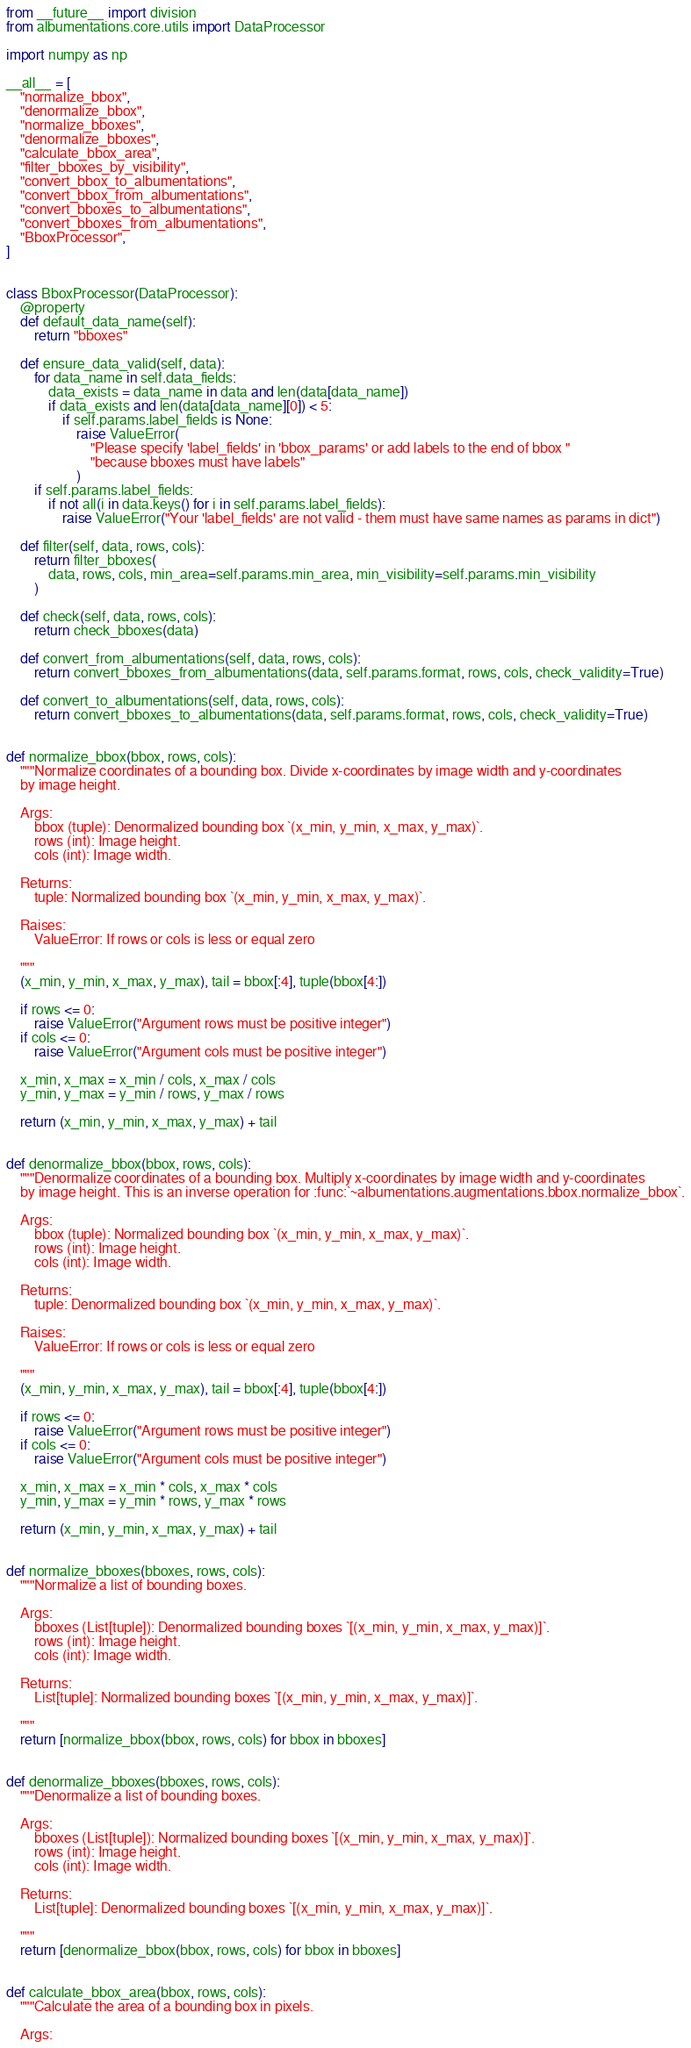Convert code to text. <code><loc_0><loc_0><loc_500><loc_500><_Python_>from __future__ import division
from albumentations.core.utils import DataProcessor

import numpy as np

__all__ = [
    "normalize_bbox",
    "denormalize_bbox",
    "normalize_bboxes",
    "denormalize_bboxes",
    "calculate_bbox_area",
    "filter_bboxes_by_visibility",
    "convert_bbox_to_albumentations",
    "convert_bbox_from_albumentations",
    "convert_bboxes_to_albumentations",
    "convert_bboxes_from_albumentations",
    "BboxProcessor",
]


class BboxProcessor(DataProcessor):
    @property
    def default_data_name(self):
        return "bboxes"

    def ensure_data_valid(self, data):
        for data_name in self.data_fields:
            data_exists = data_name in data and len(data[data_name])
            if data_exists and len(data[data_name][0]) < 5:
                if self.params.label_fields is None:
                    raise ValueError(
                        "Please specify 'label_fields' in 'bbox_params' or add labels to the end of bbox "
                        "because bboxes must have labels"
                    )
        if self.params.label_fields:
            if not all(i in data.keys() for i in self.params.label_fields):
                raise ValueError("Your 'label_fields' are not valid - them must have same names as params in dict")

    def filter(self, data, rows, cols):
        return filter_bboxes(
            data, rows, cols, min_area=self.params.min_area, min_visibility=self.params.min_visibility
        )

    def check(self, data, rows, cols):
        return check_bboxes(data)

    def convert_from_albumentations(self, data, rows, cols):
        return convert_bboxes_from_albumentations(data, self.params.format, rows, cols, check_validity=True)

    def convert_to_albumentations(self, data, rows, cols):
        return convert_bboxes_to_albumentations(data, self.params.format, rows, cols, check_validity=True)


def normalize_bbox(bbox, rows, cols):
    """Normalize coordinates of a bounding box. Divide x-coordinates by image width and y-coordinates
    by image height.

    Args:
        bbox (tuple): Denormalized bounding box `(x_min, y_min, x_max, y_max)`.
        rows (int): Image height.
        cols (int): Image width.

    Returns:
        tuple: Normalized bounding box `(x_min, y_min, x_max, y_max)`.

    Raises:
        ValueError: If rows or cols is less or equal zero

    """
    (x_min, y_min, x_max, y_max), tail = bbox[:4], tuple(bbox[4:])

    if rows <= 0:
        raise ValueError("Argument rows must be positive integer")
    if cols <= 0:
        raise ValueError("Argument cols must be positive integer")

    x_min, x_max = x_min / cols, x_max / cols
    y_min, y_max = y_min / rows, y_max / rows

    return (x_min, y_min, x_max, y_max) + tail


def denormalize_bbox(bbox, rows, cols):
    """Denormalize coordinates of a bounding box. Multiply x-coordinates by image width and y-coordinates
    by image height. This is an inverse operation for :func:`~albumentations.augmentations.bbox.normalize_bbox`.

    Args:
        bbox (tuple): Normalized bounding box `(x_min, y_min, x_max, y_max)`.
        rows (int): Image height.
        cols (int): Image width.

    Returns:
        tuple: Denormalized bounding box `(x_min, y_min, x_max, y_max)`.

    Raises:
        ValueError: If rows or cols is less or equal zero

    """
    (x_min, y_min, x_max, y_max), tail = bbox[:4], tuple(bbox[4:])

    if rows <= 0:
        raise ValueError("Argument rows must be positive integer")
    if cols <= 0:
        raise ValueError("Argument cols must be positive integer")

    x_min, x_max = x_min * cols, x_max * cols
    y_min, y_max = y_min * rows, y_max * rows

    return (x_min, y_min, x_max, y_max) + tail


def normalize_bboxes(bboxes, rows, cols):
    """Normalize a list of bounding boxes.

    Args:
        bboxes (List[tuple]): Denormalized bounding boxes `[(x_min, y_min, x_max, y_max)]`.
        rows (int): Image height.
        cols (int): Image width.

    Returns:
        List[tuple]: Normalized bounding boxes `[(x_min, y_min, x_max, y_max)]`.

    """
    return [normalize_bbox(bbox, rows, cols) for bbox in bboxes]


def denormalize_bboxes(bboxes, rows, cols):
    """Denormalize a list of bounding boxes.

    Args:
        bboxes (List[tuple]): Normalized bounding boxes `[(x_min, y_min, x_max, y_max)]`.
        rows (int): Image height.
        cols (int): Image width.

    Returns:
        List[tuple]: Denormalized bounding boxes `[(x_min, y_min, x_max, y_max)]`.

    """
    return [denormalize_bbox(bbox, rows, cols) for bbox in bboxes]


def calculate_bbox_area(bbox, rows, cols):
    """Calculate the area of a bounding box in pixels.

    Args:</code> 